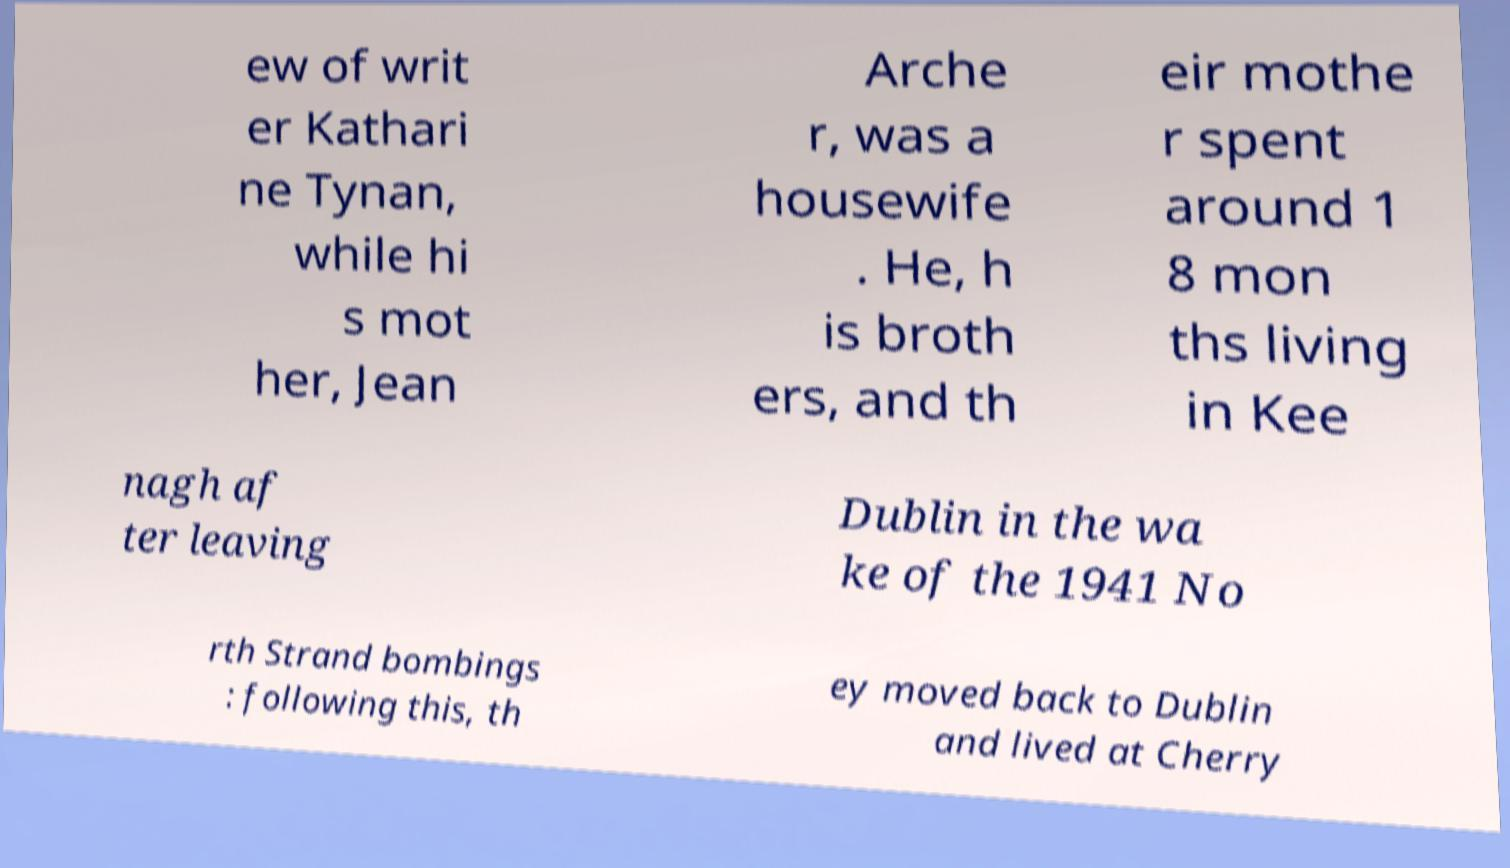Can you read and provide the text displayed in the image?This photo seems to have some interesting text. Can you extract and type it out for me? ew of writ er Kathari ne Tynan, while hi s mot her, Jean Arche r, was a housewife . He, h is broth ers, and th eir mothe r spent around 1 8 mon ths living in Kee nagh af ter leaving Dublin in the wa ke of the 1941 No rth Strand bombings : following this, th ey moved back to Dublin and lived at Cherry 